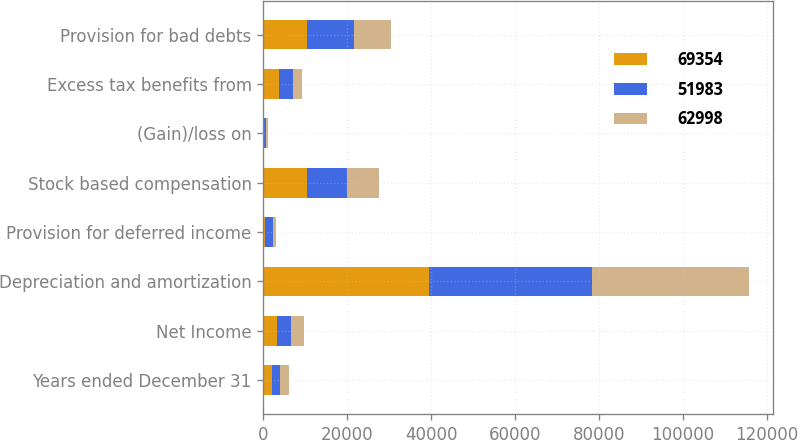Convert chart. <chart><loc_0><loc_0><loc_500><loc_500><stacked_bar_chart><ecel><fcel>Years ended December 31<fcel>Net Income<fcel>Depreciation and amortization<fcel>Provision for deferred income<fcel>Stock based compensation<fcel>(Gain)/loss on<fcel>Excess tax benefits from<fcel>Provision for bad debts<nl><fcel>69354<fcel>2013<fcel>3231<fcel>39571<fcel>356<fcel>10427<fcel>165<fcel>3722<fcel>10388<nl><fcel>51983<fcel>2012<fcel>3231<fcel>38655<fcel>1870<fcel>9494<fcel>468<fcel>3231<fcel>11095<nl><fcel>62998<fcel>2011<fcel>3231<fcel>37503<fcel>784<fcel>7555<fcel>405<fcel>2367<fcel>8879<nl></chart> 